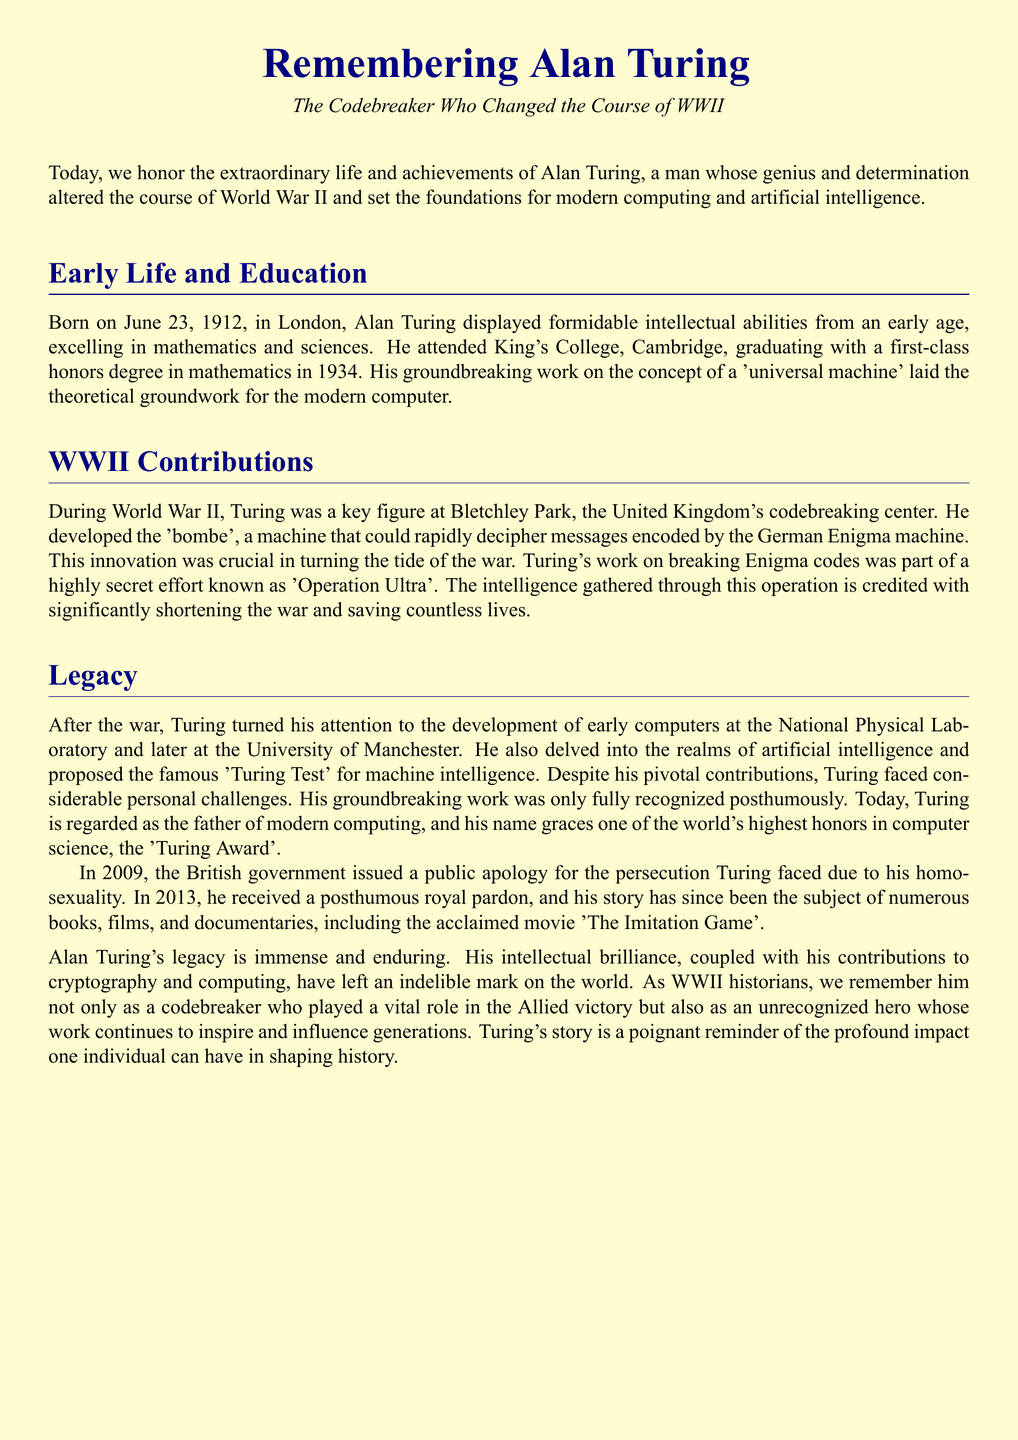What is Alan Turing's birth date? The document states that Alan Turing was born on June 23, 1912.
Answer: June 23, 1912 What was Turing's degree from Cambridge? The document mentions that Turing graduated with a first-class honors degree in mathematics.
Answer: First-class honors degree in mathematics What machine did Turing develop? According to the document, Turing developed the 'bombe'.
Answer: Bombe What operation was Turing's codebreaking effort part of? The document states that Turing's work was part of 'Operation Ultra'.
Answer: Operation Ultra What prestigious award is named after Turing? The document mentions the 'Turing Award' as one of the world's highest honors in computer science.
Answer: Turing Award How did Turing's work influence WWII? The document describes that Turing's codebreaking was crucial in turning the tide of the war.
Answer: Turning the tide of the war What test did Turing propose? The document states that Turing proposed the 'Turing Test' for machine intelligence.
Answer: Turing Test What was issued by the British government in 2009? The document mentions that the British government issued a public apology for the persecution Turing faced.
Answer: Public apology What is one artistic representation of Turing's story? The document references the acclaimed movie 'The Imitation Game' as an artistic representation of his story.
Answer: The Imitation Game 